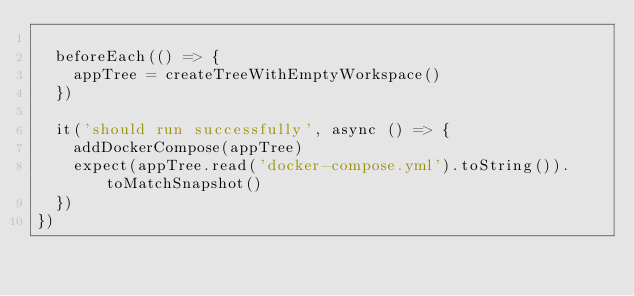<code> <loc_0><loc_0><loc_500><loc_500><_TypeScript_>
  beforeEach(() => {
    appTree = createTreeWithEmptyWorkspace()
  })

  it('should run successfully', async () => {
    addDockerCompose(appTree)
    expect(appTree.read('docker-compose.yml').toString()).toMatchSnapshot()
  })
})
</code> 